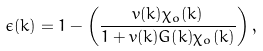Convert formula to latex. <formula><loc_0><loc_0><loc_500><loc_500>\epsilon ( k ) = 1 - \left ( \frac { v ( k ) \chi _ { o } ( k ) } { 1 + v ( k ) G ( k ) \chi _ { o } ( k ) } \right ) ,</formula> 